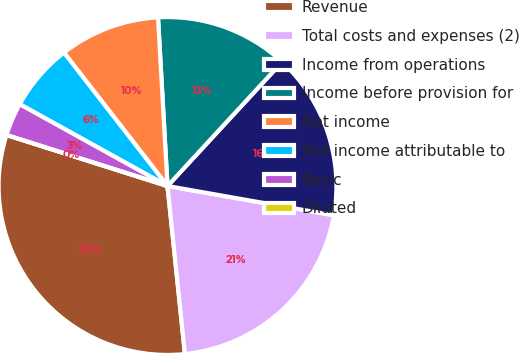<chart> <loc_0><loc_0><loc_500><loc_500><pie_chart><fcel>Revenue<fcel>Total costs and expenses (2)<fcel>Income from operations<fcel>Income before provision for<fcel>Net income<fcel>Net income attributable to<fcel>Basic<fcel>Diluted<nl><fcel>31.53%<fcel>20.58%<fcel>15.91%<fcel>12.76%<fcel>9.61%<fcel>6.45%<fcel>3.16%<fcel>0.0%<nl></chart> 